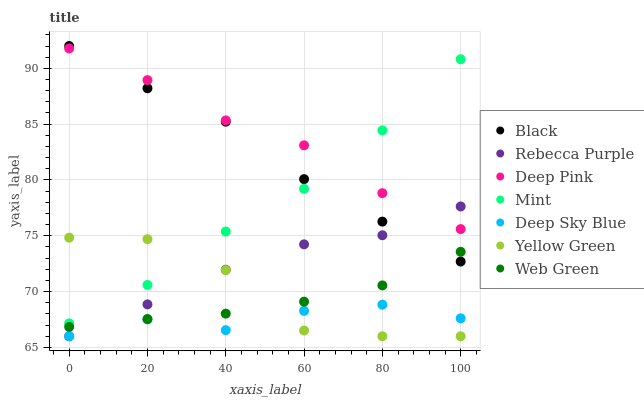Does Deep Sky Blue have the minimum area under the curve?
Answer yes or no. Yes. Does Deep Pink have the maximum area under the curve?
Answer yes or no. Yes. Does Yellow Green have the minimum area under the curve?
Answer yes or no. No. Does Yellow Green have the maximum area under the curve?
Answer yes or no. No. Is Web Green the smoothest?
Answer yes or no. Yes. Is Yellow Green the roughest?
Answer yes or no. Yes. Is Yellow Green the smoothest?
Answer yes or no. No. Is Web Green the roughest?
Answer yes or no. No. Does Yellow Green have the lowest value?
Answer yes or no. Yes. Does Web Green have the lowest value?
Answer yes or no. No. Does Black have the highest value?
Answer yes or no. Yes. Does Yellow Green have the highest value?
Answer yes or no. No. Is Deep Sky Blue less than Web Green?
Answer yes or no. Yes. Is Mint greater than Rebecca Purple?
Answer yes or no. Yes. Does Rebecca Purple intersect Web Green?
Answer yes or no. Yes. Is Rebecca Purple less than Web Green?
Answer yes or no. No. Is Rebecca Purple greater than Web Green?
Answer yes or no. No. Does Deep Sky Blue intersect Web Green?
Answer yes or no. No. 